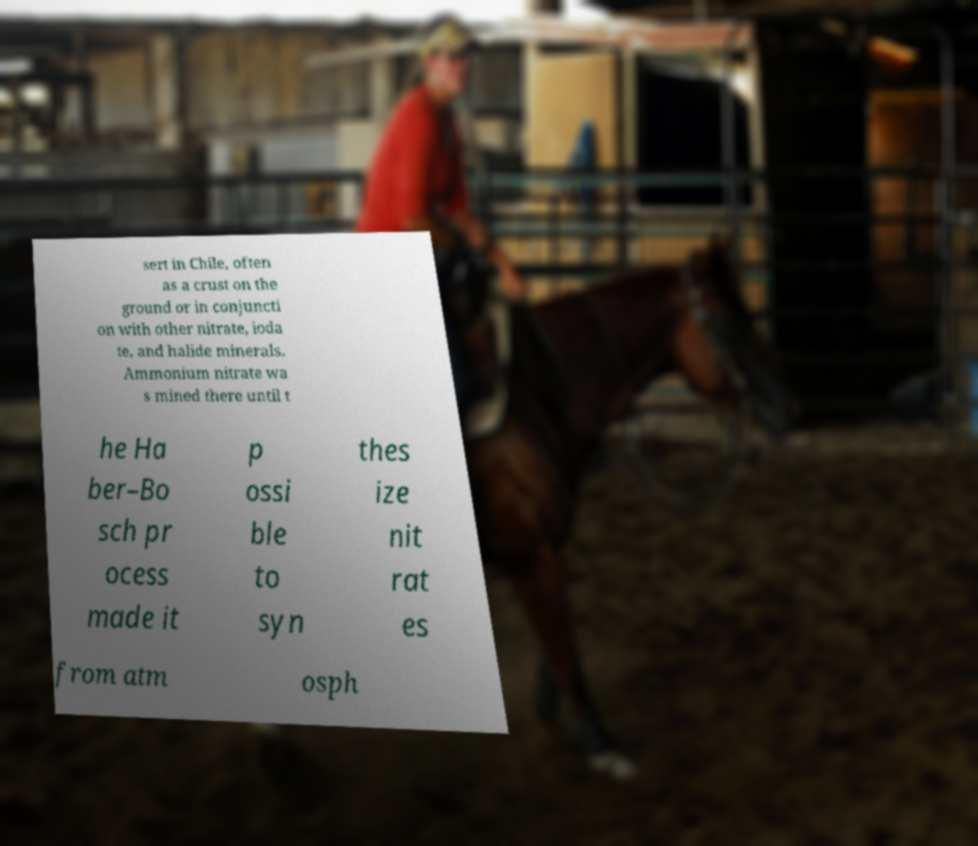Please identify and transcribe the text found in this image. sert in Chile, often as a crust on the ground or in conjuncti on with other nitrate, ioda te, and halide minerals. Ammonium nitrate wa s mined there until t he Ha ber–Bo sch pr ocess made it p ossi ble to syn thes ize nit rat es from atm osph 